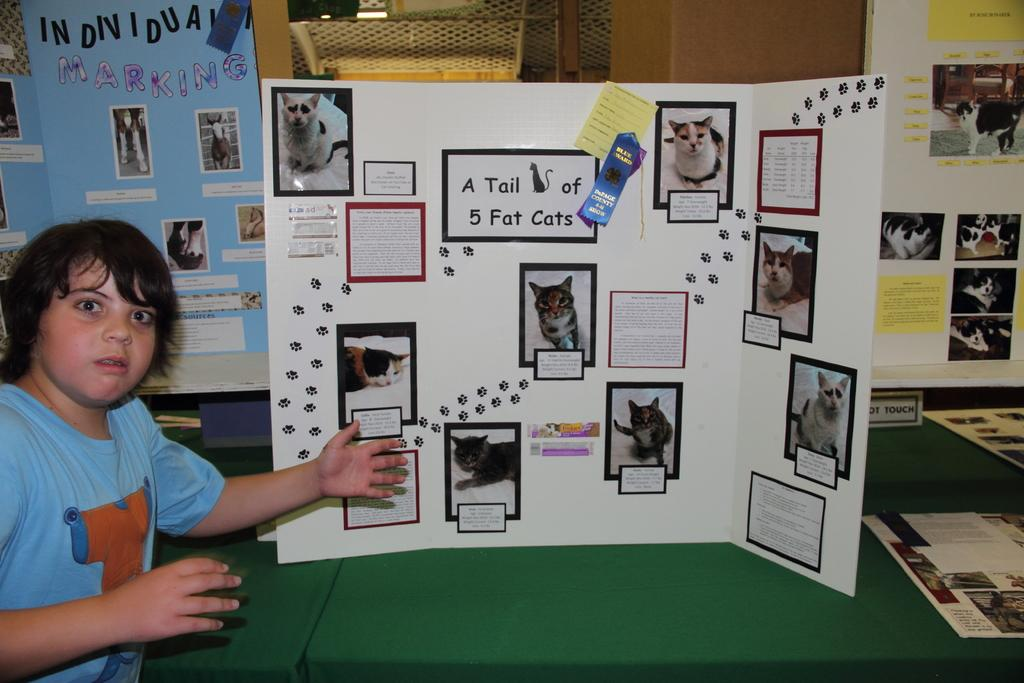<image>
Offer a succinct explanation of the picture presented. a poster board that has the word tail on it 